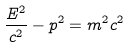Convert formula to latex. <formula><loc_0><loc_0><loc_500><loc_500>\frac { E ^ { 2 } } { c ^ { 2 } } - p ^ { 2 } = m ^ { 2 } c ^ { 2 }</formula> 